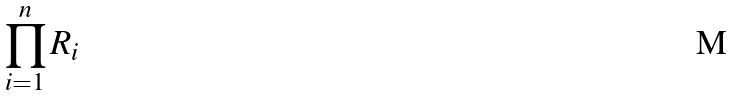Convert formula to latex. <formula><loc_0><loc_0><loc_500><loc_500>\prod _ { i = 1 } ^ { n } R _ { i }</formula> 